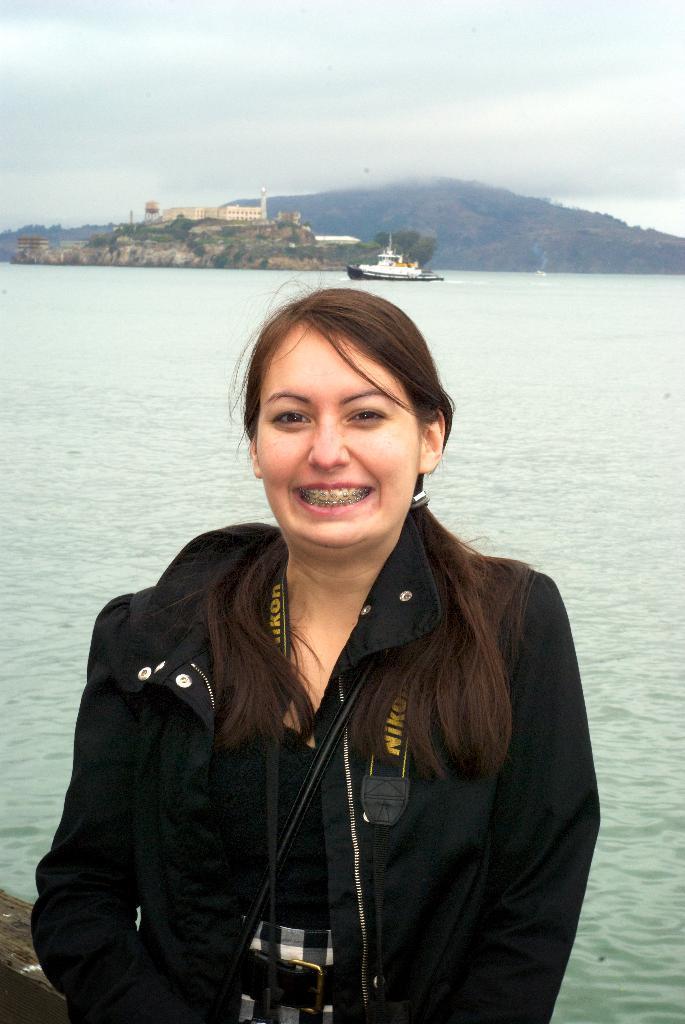How would you summarize this image in a sentence or two? In this picture I can see a woman standing, behind there is a ship on the water surface. 